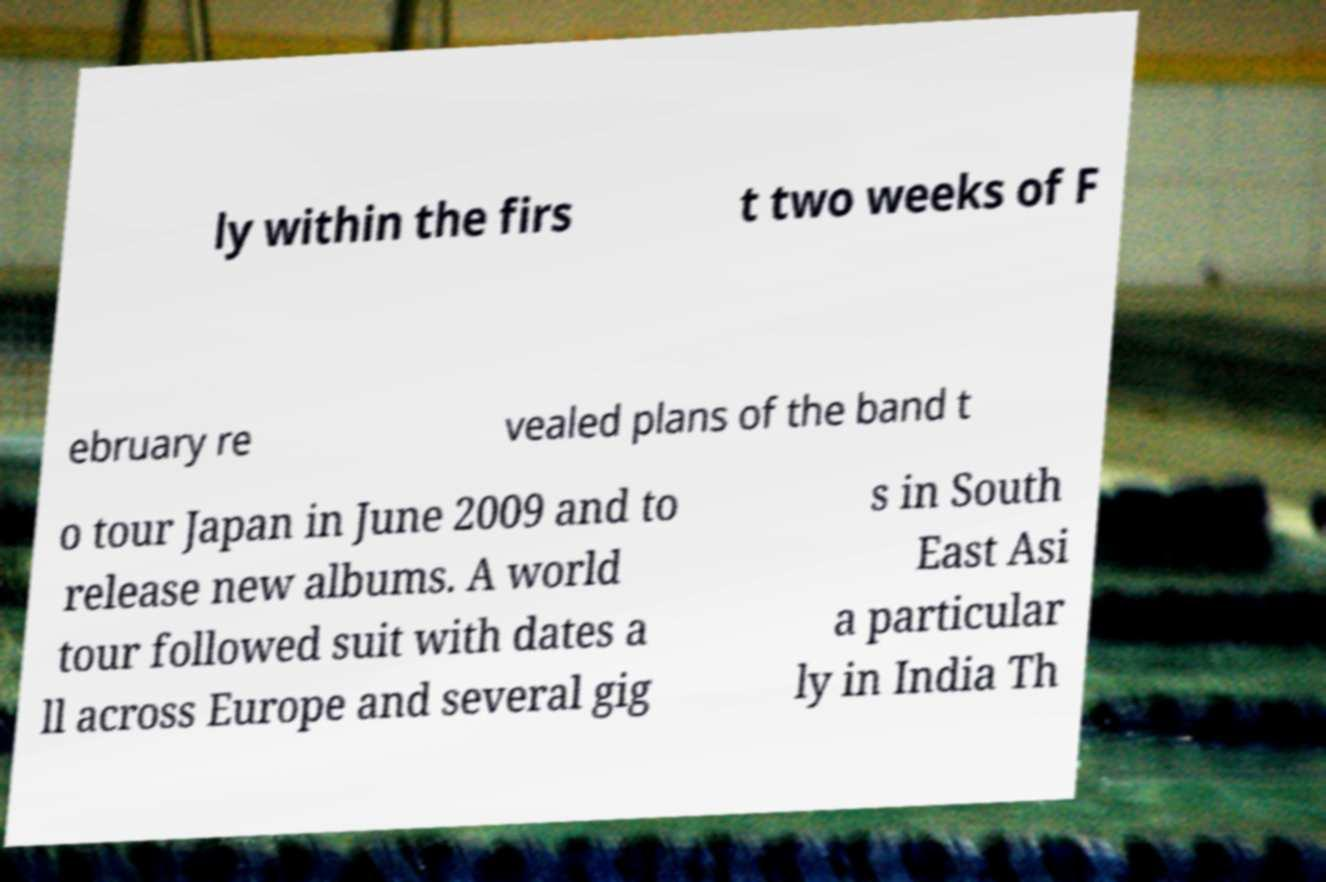Could you extract and type out the text from this image? ly within the firs t two weeks of F ebruary re vealed plans of the band t o tour Japan in June 2009 and to release new albums. A world tour followed suit with dates a ll across Europe and several gig s in South East Asi a particular ly in India Th 